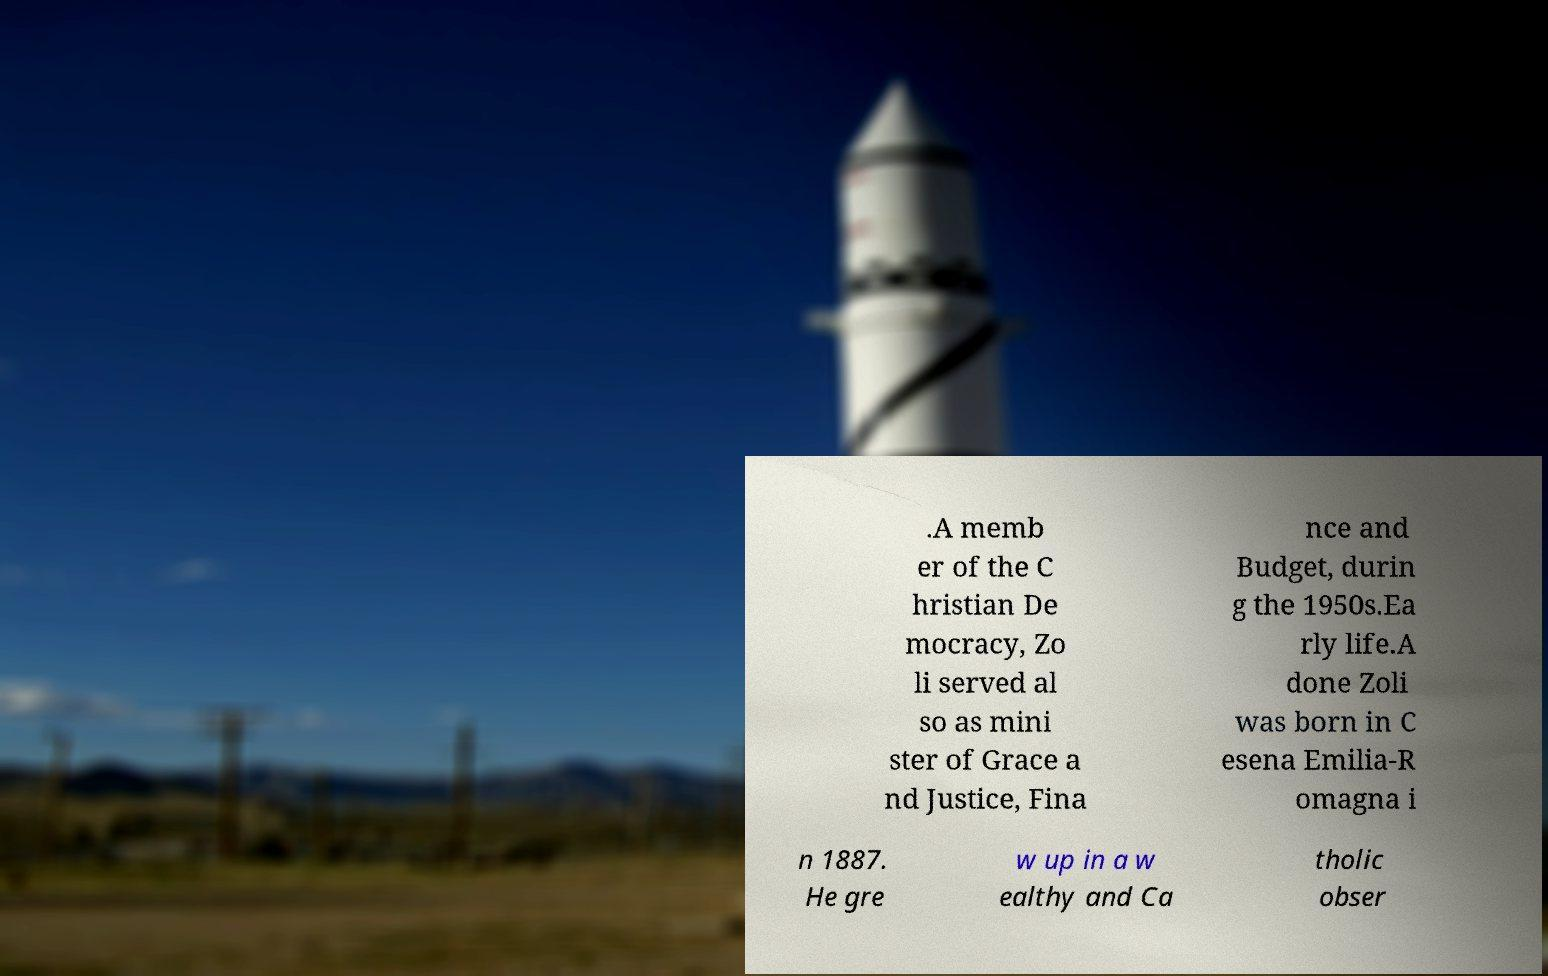Could you assist in decoding the text presented in this image and type it out clearly? .A memb er of the C hristian De mocracy, Zo li served al so as mini ster of Grace a nd Justice, Fina nce and Budget, durin g the 1950s.Ea rly life.A done Zoli was born in C esena Emilia-R omagna i n 1887. He gre w up in a w ealthy and Ca tholic obser 